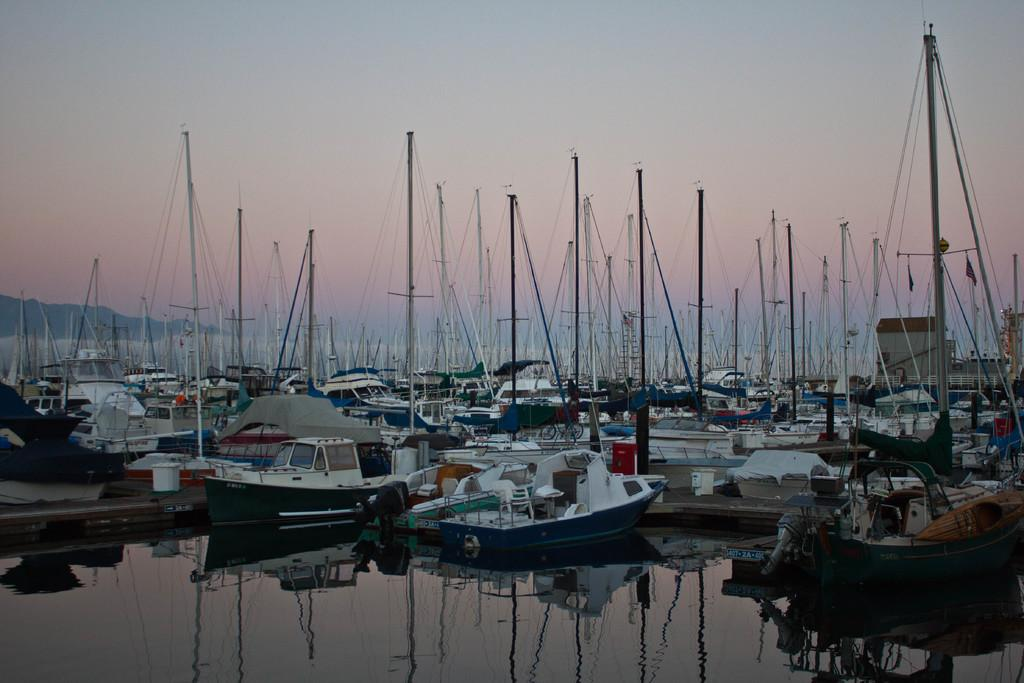What is in the water in the image? There are ships in the water in the image. What objects can be seen in the image besides the ships? There are poles, flags, and ropes in the image. What is the background of the image? There are mountains in the image, and the sky is visible. What type of silk is being used to construct the building in the image? There is no building present in the image, so it is not possible to determine what type of silk might be used in its construction. --- Facts: 1. There is a person sitting on a chair in the image. 2. The person is holding a book. 3. There is a table in the image. 4. The table has a lamp on it. 5. There is a window in the image. Absurd Topics: parrot, bicycle, ocean Conversation: What is the person in the image doing? The person is sitting on a chair in the image. What object is the person holding? The person is holding a book. What furniture is present in the image besides the chair? There is a table in the image. What is on the table in the image? The table has a lamp on it. What can be seen through the window in the image? There is a window in the image, but the facts do not specify what can be seen through it. Reasoning: Let's think step by step in order to produce the conversation. We start by identifying the main subject in the image, which is the person sitting on a chair. Then, we expand the conversation to include other objects and elements that are also visible, such as the book, table, lamp, and window. Each question is designed to elicit a specific detail about the image that is known from the provided facts. Absurd Question/Answer: Can you tell me how many parrots are sitting on the bicycle outside the window in the image? There is no bicycle or parrots present in the image, and therefore no such activity can be observed. 